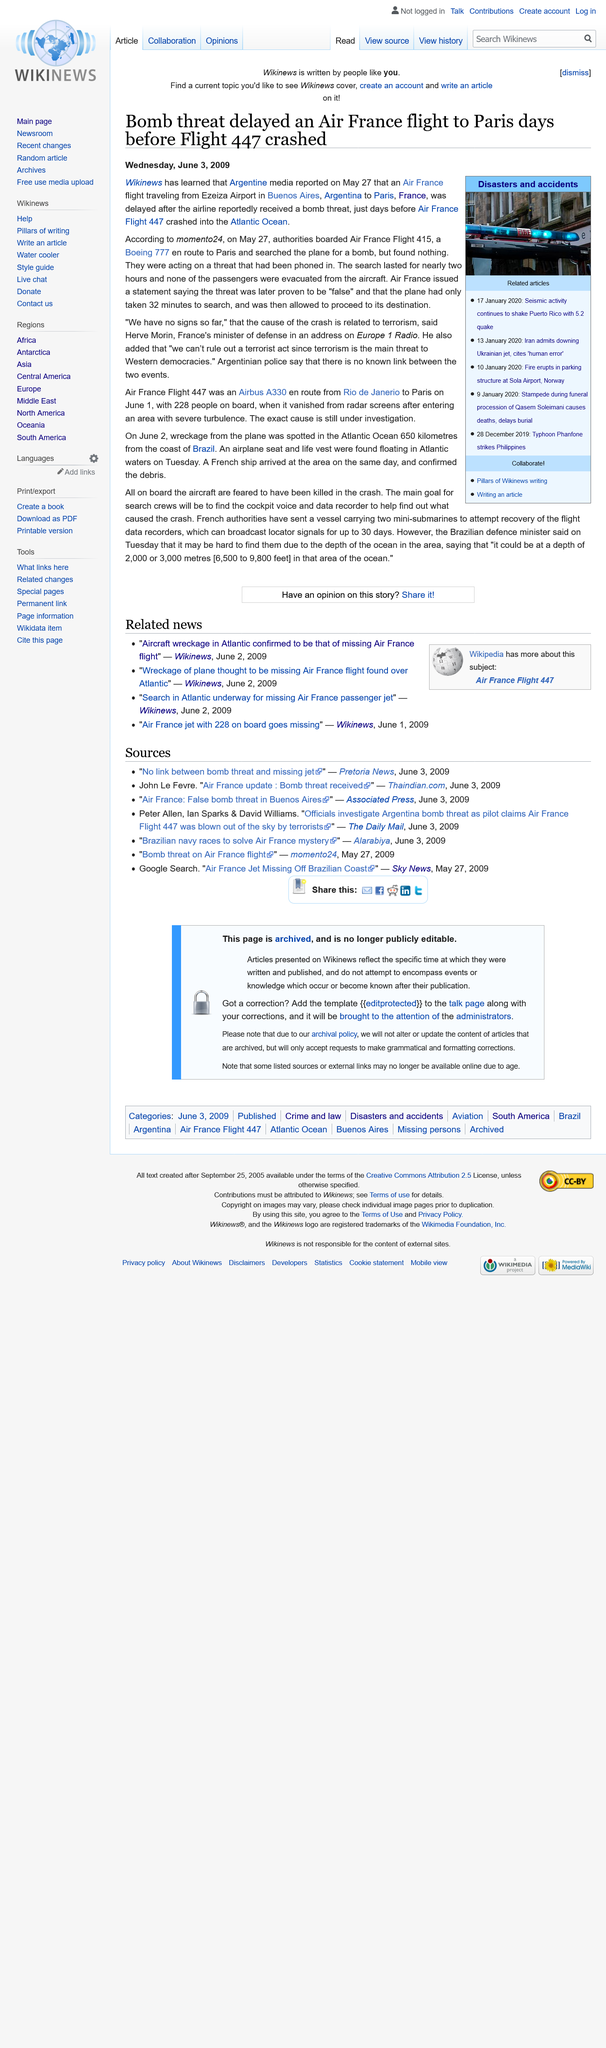Highlight a few significant elements in this photo. The speaker stated that the kind of plane that was involved in the incident was a Boeing 777. The authorities were seeking a bomb on the plane. The date on which this was published is Wednesday, June 3, 2009. 